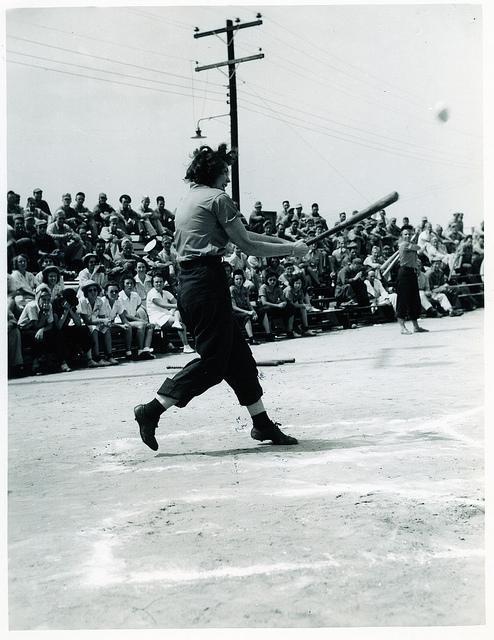How many people are in the picture?
Give a very brief answer. 5. How many donuts have a pumpkin face?
Give a very brief answer. 0. 